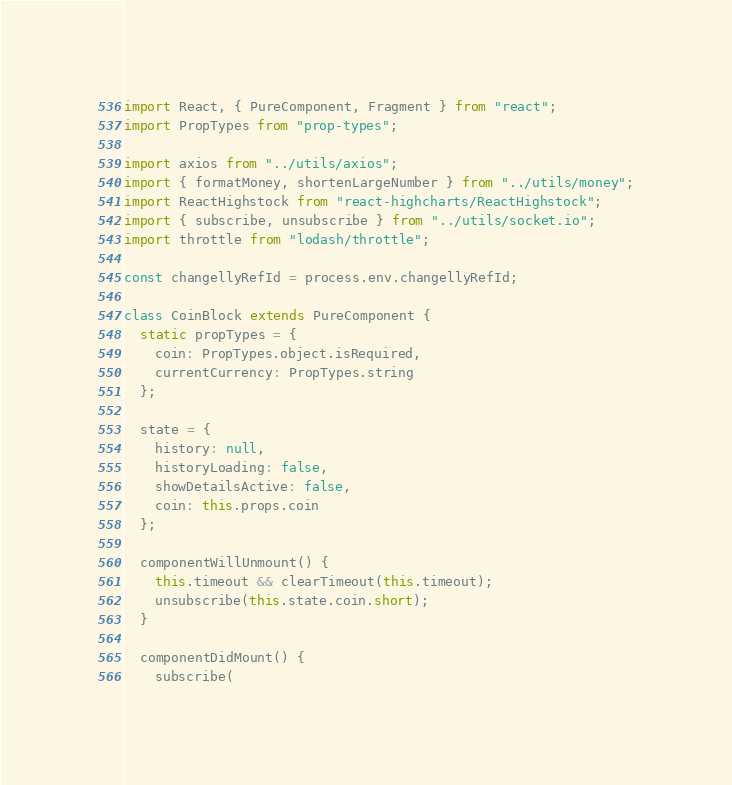Convert code to text. <code><loc_0><loc_0><loc_500><loc_500><_JavaScript_>import React, { PureComponent, Fragment } from "react";
import PropTypes from "prop-types";

import axios from "../utils/axios";
import { formatMoney, shortenLargeNumber } from "../utils/money";
import ReactHighstock from "react-highcharts/ReactHighstock";
import { subscribe, unsubscribe } from "../utils/socket.io";
import throttle from "lodash/throttle";

const changellyRefId = process.env.changellyRefId;

class CoinBlock extends PureComponent {
  static propTypes = {
    coin: PropTypes.object.isRequired,
    currentCurrency: PropTypes.string
  };

  state = {
    history: null,
    historyLoading: false,
    showDetailsActive: false,
    coin: this.props.coin
  };

  componentWillUnmount() {
    this.timeout && clearTimeout(this.timeout);
    unsubscribe(this.state.coin.short);
  }

  componentDidMount() {
    subscribe(</code> 